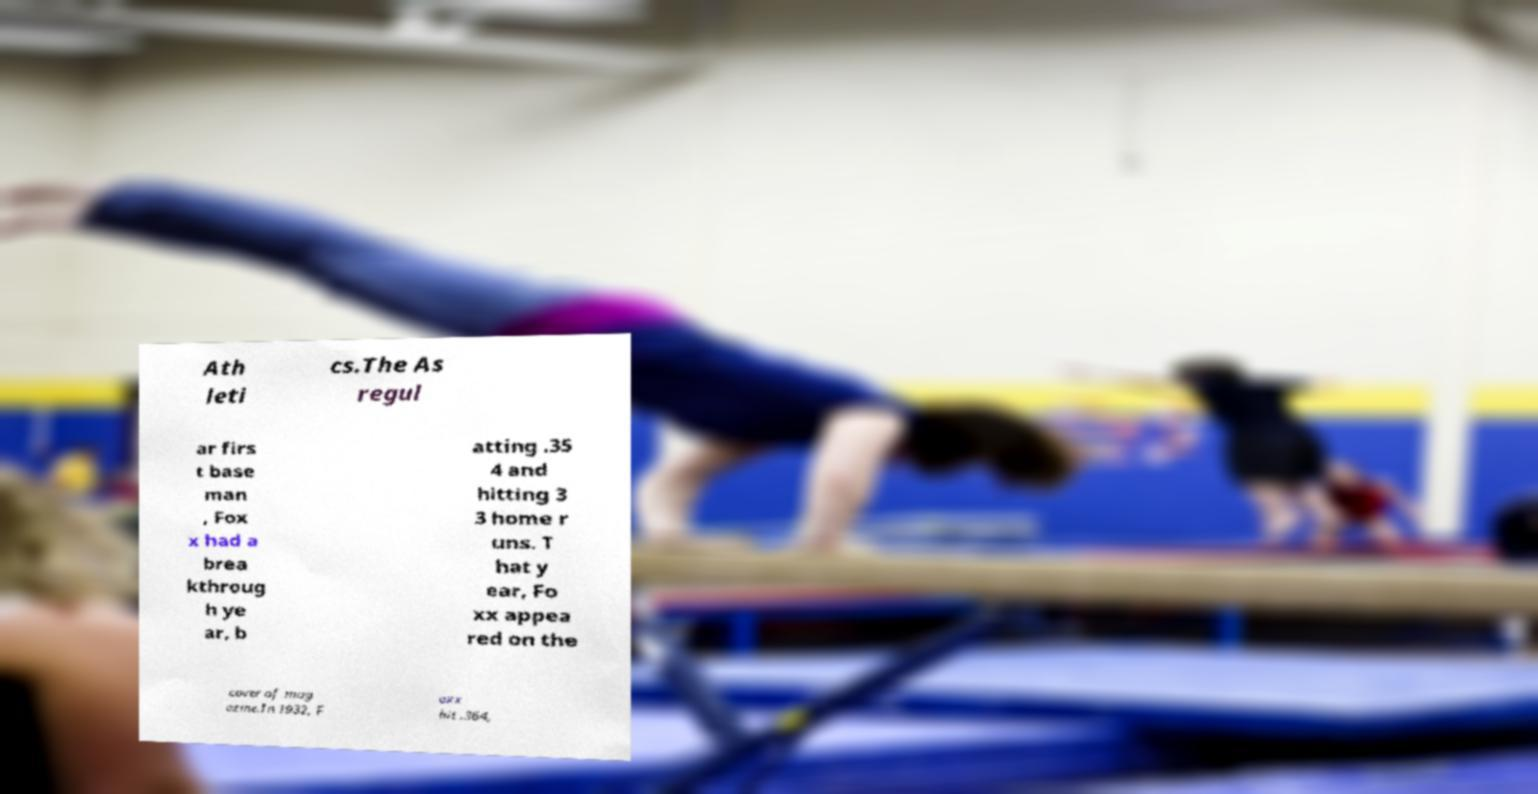Please read and relay the text visible in this image. What does it say? Ath leti cs.The As regul ar firs t base man , Fox x had a brea kthroug h ye ar, b atting .35 4 and hitting 3 3 home r uns. T hat y ear, Fo xx appea red on the cover of mag azine.In 1932, F oxx hit .364, 